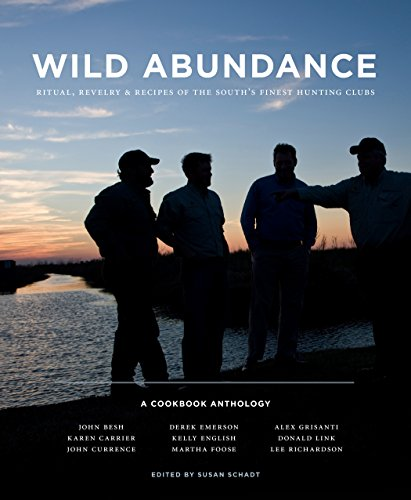What is the genre of this book? This book falls under the genres of Cookbooks, Food, and Wine. It is designed to offer readers a blend of culinary guidance enriched with cultural insights from the South, ideal for those interested in both cooking and regional traditions. 